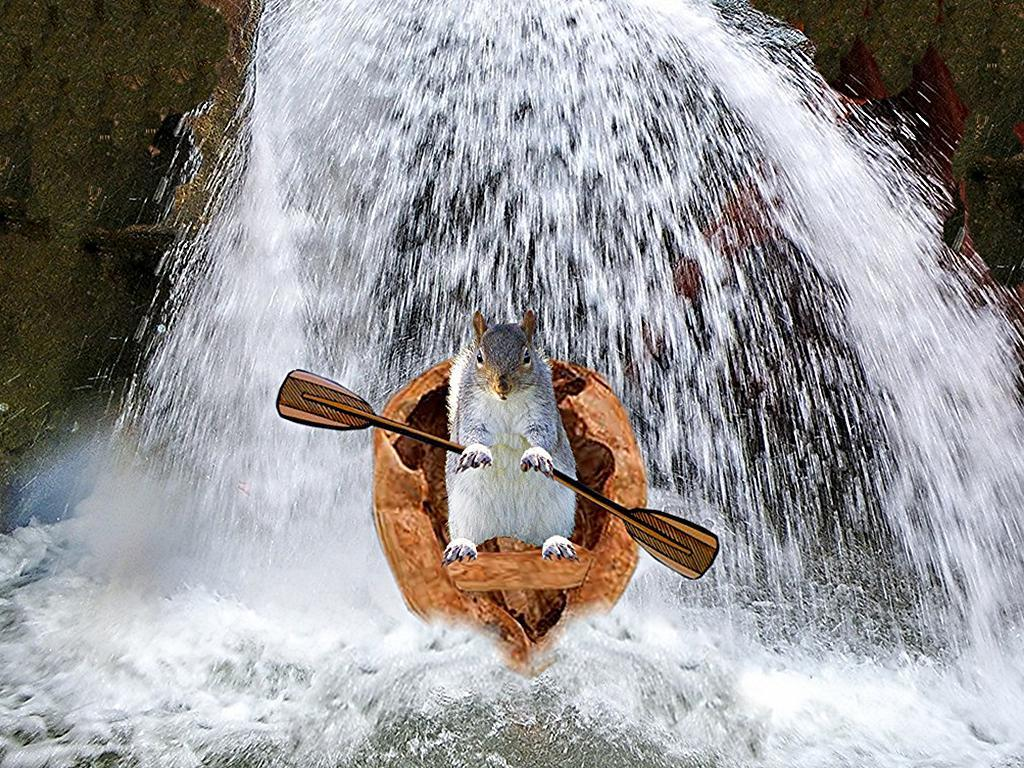What animal is in the boat in the image? There is a squirrel in the boat in the image. What is the squirrel doing in the boat? The squirrel is holding the boat oars. What can be seen in the background of the image? There is a waterfall in the background of the image. What type of soda is the squirrel drinking in the image? There is no soda present in the image; the squirrel is holding boat oars. Is there any oatmeal visible in the image? No, there is no oatmeal present in the image. 